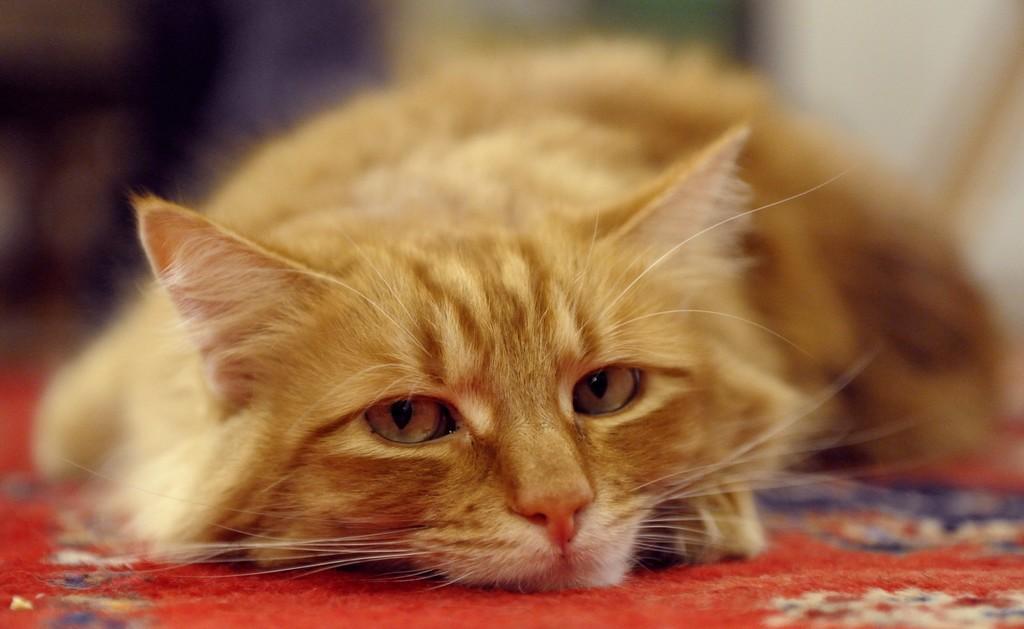Please provide a concise description of this image. In the center of the image we can see one carpet. On the carpet, we can see one cat, which is brown in color. 